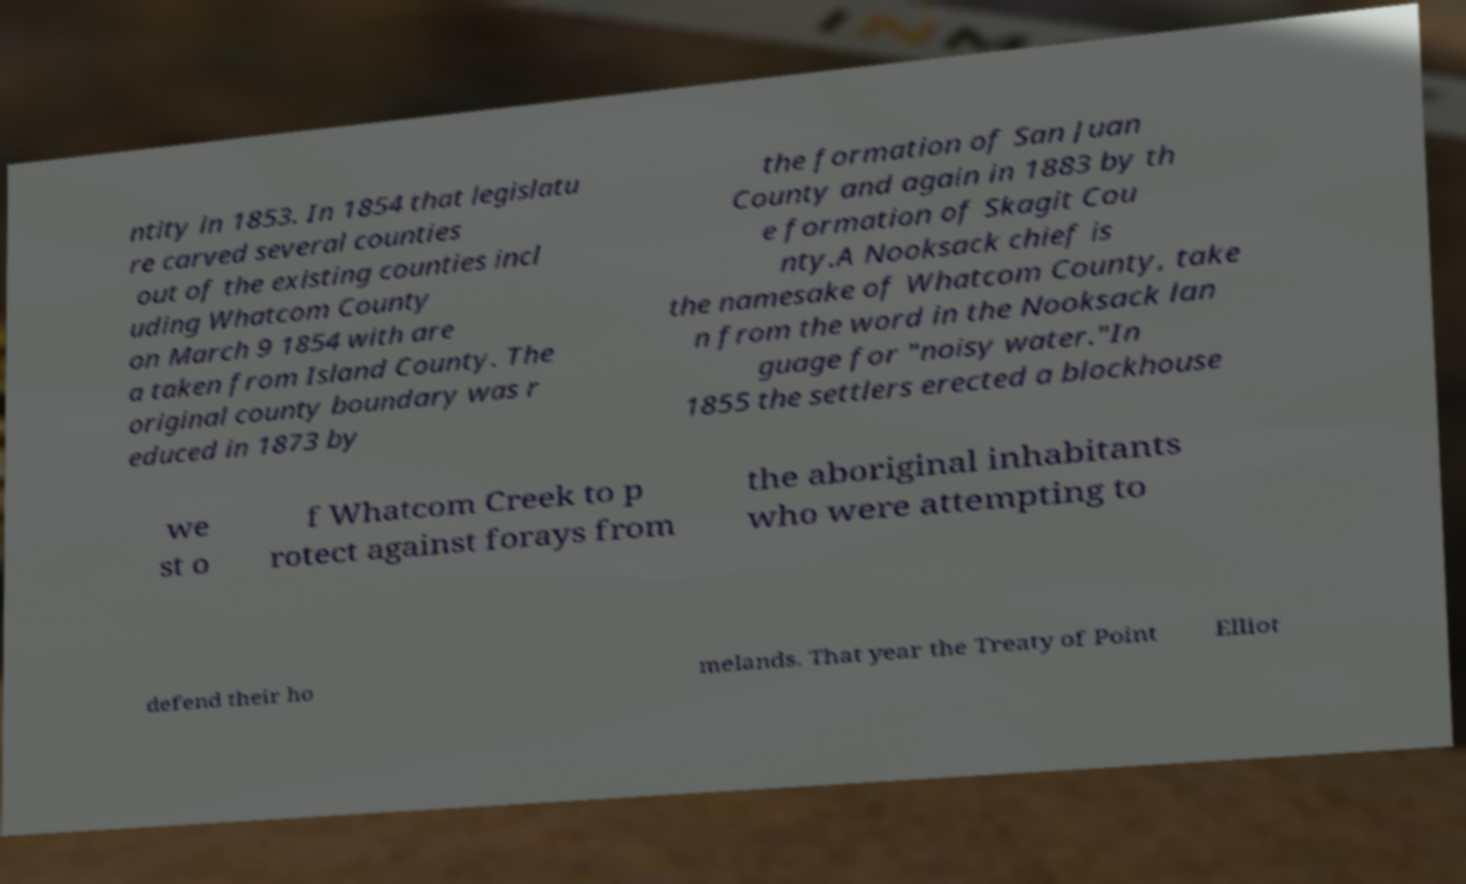For documentation purposes, I need the text within this image transcribed. Could you provide that? ntity in 1853. In 1854 that legislatu re carved several counties out of the existing counties incl uding Whatcom County on March 9 1854 with are a taken from Island County. The original county boundary was r educed in 1873 by the formation of San Juan County and again in 1883 by th e formation of Skagit Cou nty.A Nooksack chief is the namesake of Whatcom County, take n from the word in the Nooksack lan guage for "noisy water."In 1855 the settlers erected a blockhouse we st o f Whatcom Creek to p rotect against forays from the aboriginal inhabitants who were attempting to defend their ho melands. That year the Treaty of Point Elliot 